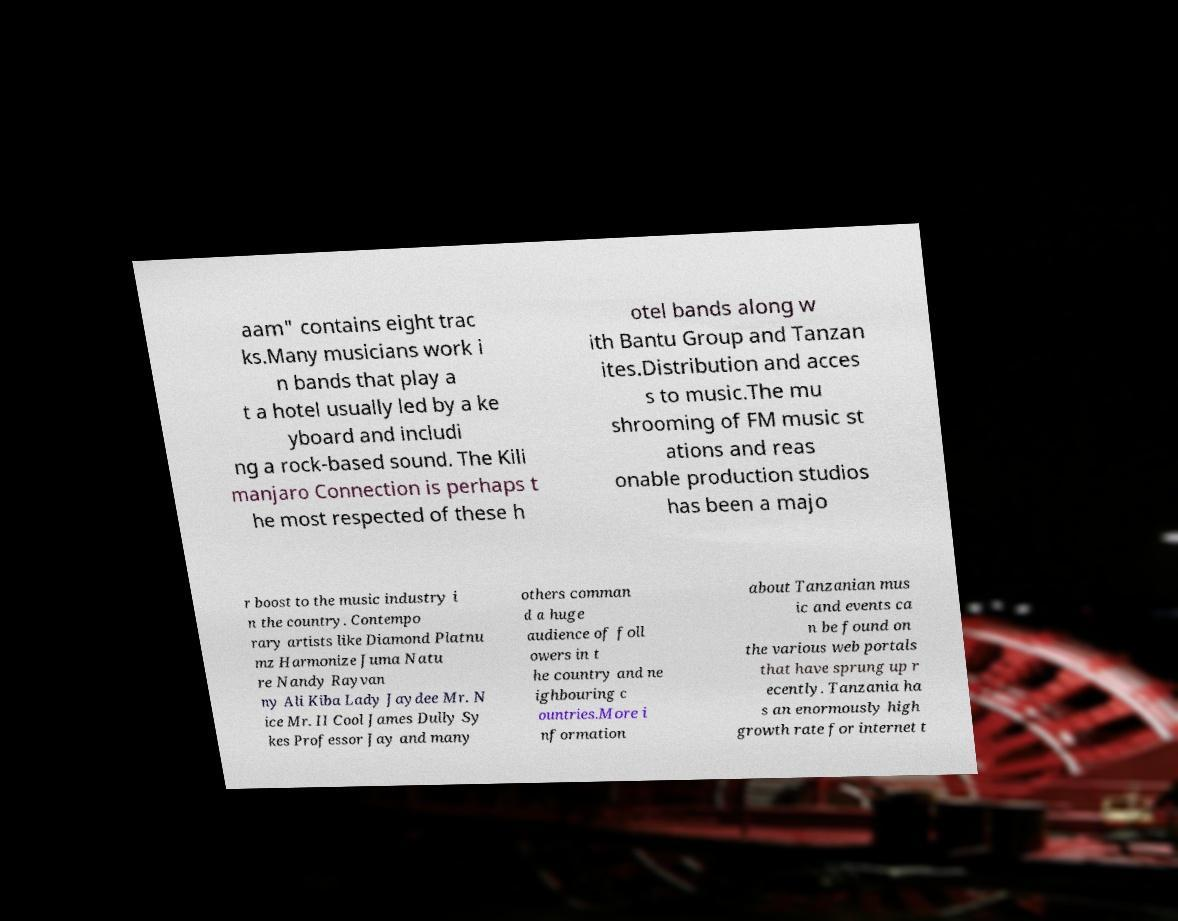Please read and relay the text visible in this image. What does it say? aam" contains eight trac ks.Many musicians work i n bands that play a t a hotel usually led by a ke yboard and includi ng a rock-based sound. The Kili manjaro Connection is perhaps t he most respected of these h otel bands along w ith Bantu Group and Tanzan ites.Distribution and acces s to music.The mu shrooming of FM music st ations and reas onable production studios has been a majo r boost to the music industry i n the country. Contempo rary artists like Diamond Platnu mz Harmonize Juma Natu re Nandy Rayvan ny Ali Kiba Lady Jaydee Mr. N ice Mr. II Cool James Dully Sy kes Professor Jay and many others comman d a huge audience of foll owers in t he country and ne ighbouring c ountries.More i nformation about Tanzanian mus ic and events ca n be found on the various web portals that have sprung up r ecently. Tanzania ha s an enormously high growth rate for internet t 